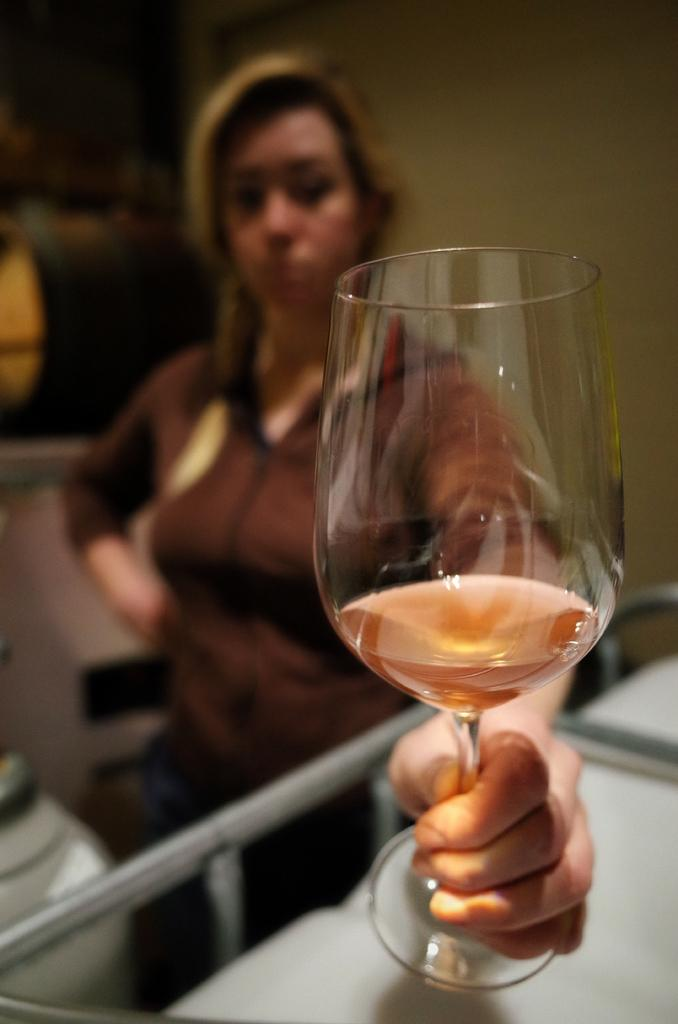What is the main subject of the image? There is a woman standing in the image. What is the woman wearing? The woman is wearing clothes. What is the woman holding in her hand? The woman is holding a wine glass in her hand. Can you describe the background of the image? The background of the image is blurred. What type of railway can be seen in the background of the image? There is no railway present in the image; the background is blurred. How many bells are hanging from the woman's neck in the image? There are no bells visible in the image; the woman is holding a wine glass. 